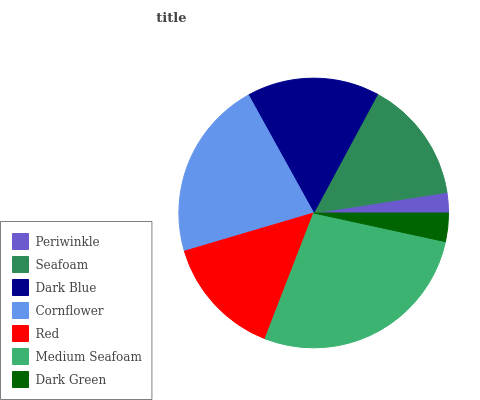Is Periwinkle the minimum?
Answer yes or no. Yes. Is Medium Seafoam the maximum?
Answer yes or no. Yes. Is Seafoam the minimum?
Answer yes or no. No. Is Seafoam the maximum?
Answer yes or no. No. Is Seafoam greater than Periwinkle?
Answer yes or no. Yes. Is Periwinkle less than Seafoam?
Answer yes or no. Yes. Is Periwinkle greater than Seafoam?
Answer yes or no. No. Is Seafoam less than Periwinkle?
Answer yes or no. No. Is Seafoam the high median?
Answer yes or no. Yes. Is Seafoam the low median?
Answer yes or no. Yes. Is Red the high median?
Answer yes or no. No. Is Dark Green the low median?
Answer yes or no. No. 